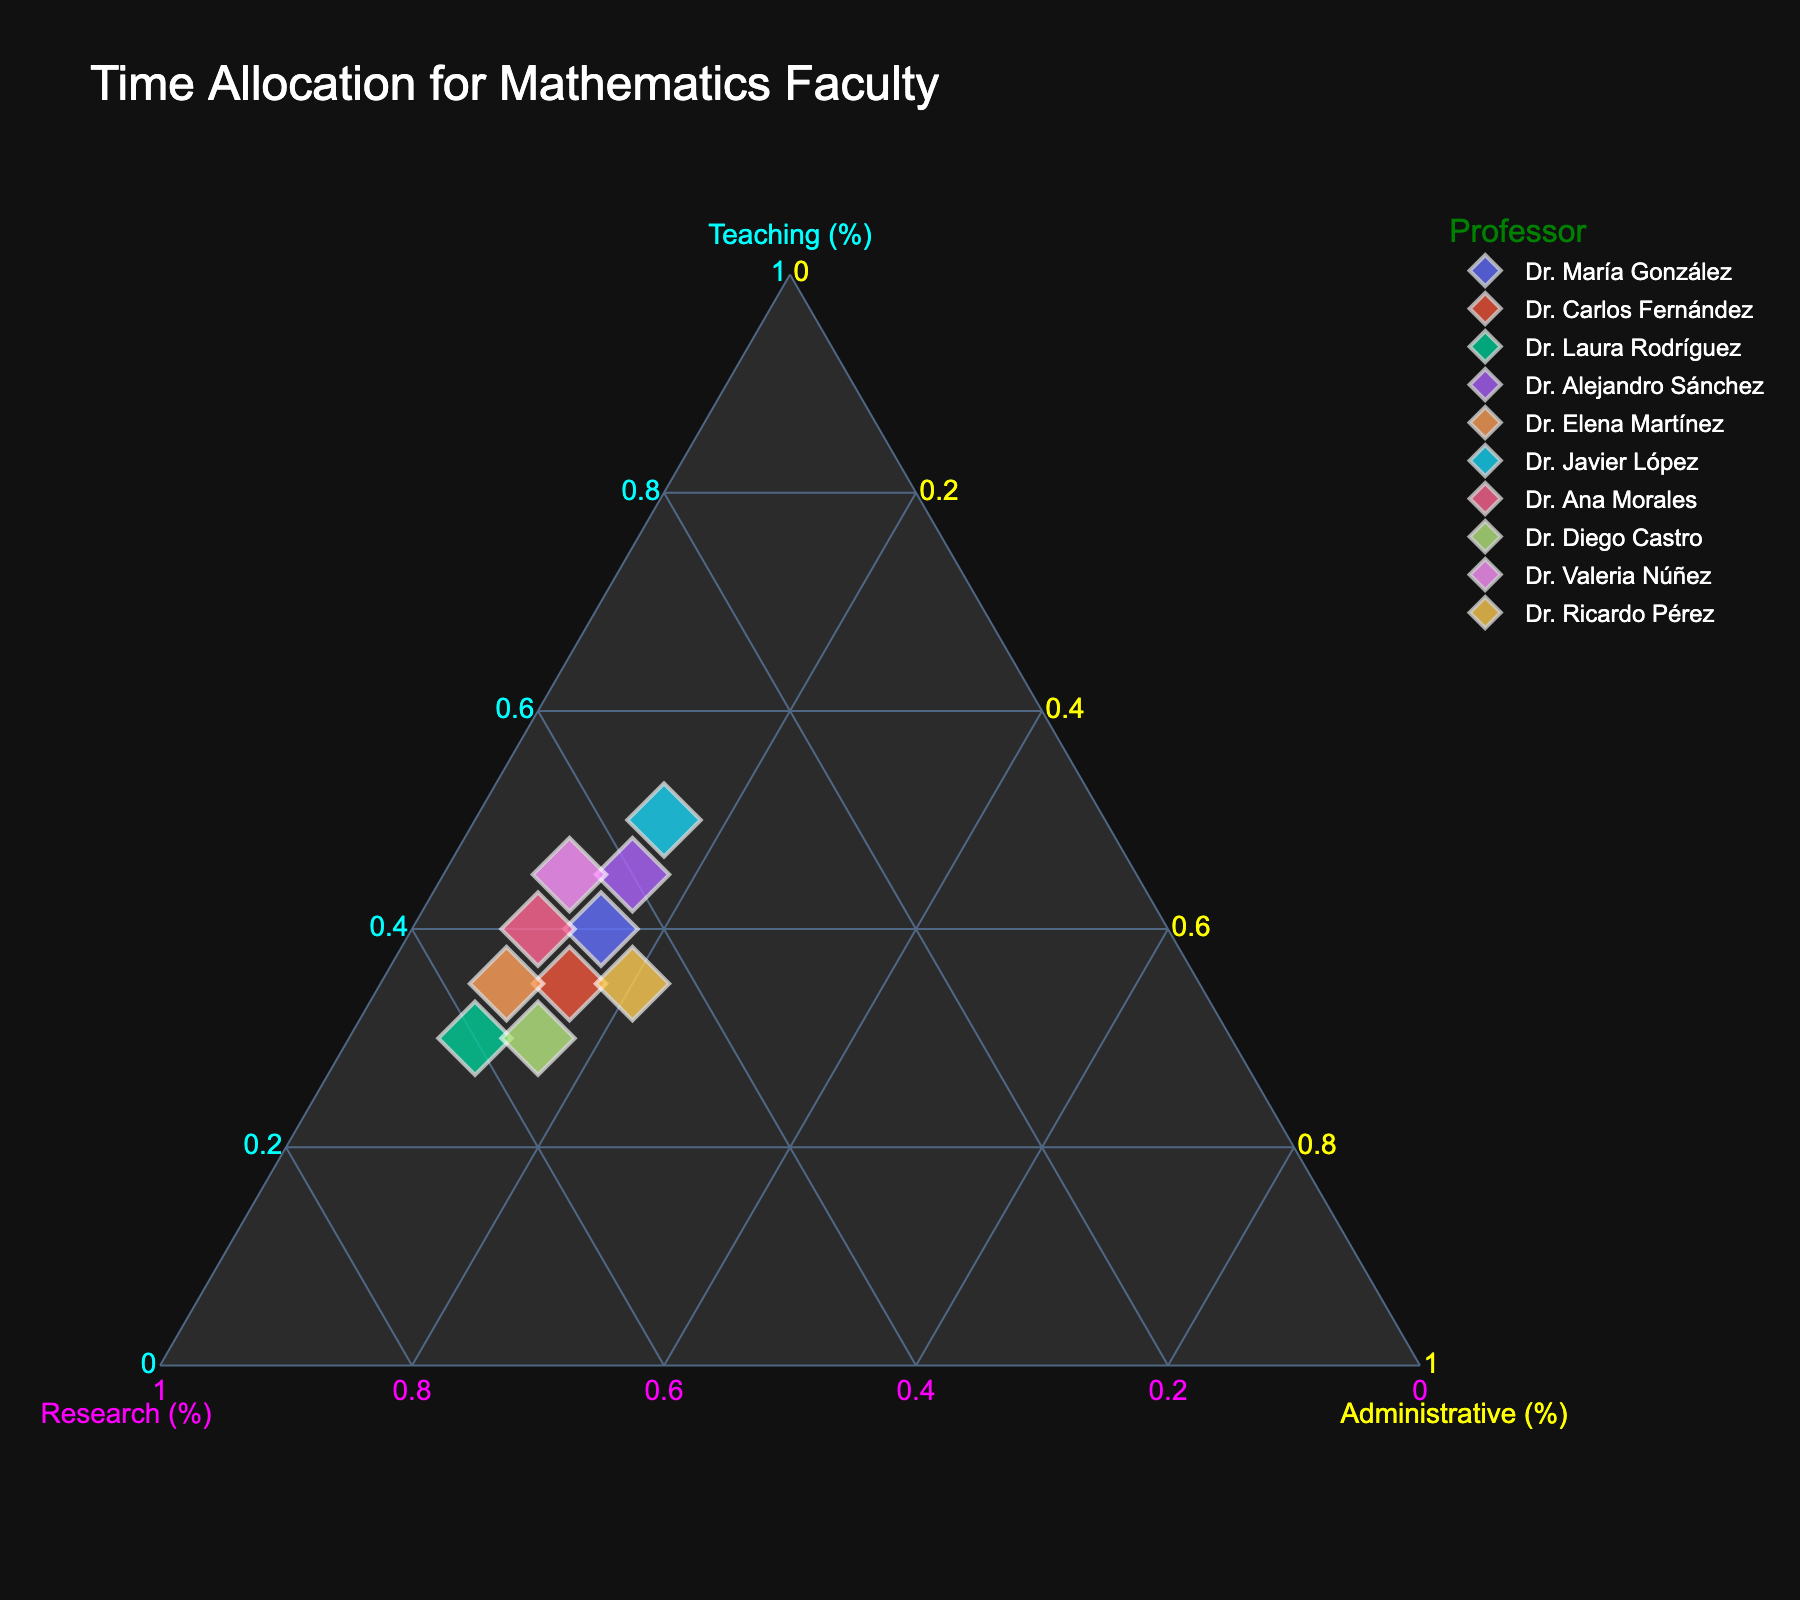How many professors' data points are plotted in the ternary plot? Count the number of distinct points in the ternary plot. There are 10 professors' data points plotted.
Answer: 10 What is the percentage of time Dr. Laura Rodríguez spends on administrative tasks? Locate the point representing Dr. Laura Rodríguez in the ternary plot and read the percentage assigned to the 'Administrative' axis. She spends 10% of her time on administrative tasks.
Answer: 10% Who spends the highest percentage of time on teaching? Identify the professor whose data point is closest to the 'Teaching' vertex (100% Teaching). Dr. Javier López spends the highest percentage of time on teaching, at 50%.
Answer: Dr. Javier López Which professors spend an equal percentage of time on research and teaching? Find the data points plotted along the line where 'Teaching' and 'Research' percentages are equal. Dr. María González and Dr. Valeria Núñez both spend equal percentages on teaching and research, at 45%.
Answer: Dr. María González, Dr. Valeria Núñez What is the average percentage of time spent on administrative tasks by all professors? Sum up the percentages spent on administrative tasks by each professor, then divide by the number of professors. (15+15+10+15+10+15+10+15+10+20) = 125%, divided by 10 professors gives 12.5%.
Answer: 12.5% Which professor's time allocation is closest to being equally divided among teaching, research, and administrative tasks? Determine the data point that is closest to the center of the ternary plot, where percentages of teaching, research, and administrative tasks would be around 33.3% each. Dr. Ricardo Pérez's allocation (35% teaching, 45% research, 20% administrative) is the closest.
Answer: Dr. Ricardo Pérez Compare the time spent on research between Dr. Elena Martínez and Dr. Diego Castro. Who spends more? Locate both professors' data points on the ternary plot and compare the 'Research' percentages. Dr. Diego Castro spends 55% of his time on research, which is the same as Dr. Elena Martínez's 55%.
Answer: They spend the same What is the mode of the time spent on administrative tasks among the professors? Identify the most frequently occurring percentage in the 'Administrative' column from the dataset. The most frequent value is 15%, appearing 5 times.
Answer: 15% Find the professor who spends the least amount of time on research. Look for the data point closest to the 'Administrative' and 'Teaching' axes, as 'Research' will be minimal there. Dr. Javier López spends the least time on research, at 35%.
Answer: Dr. Javier López 